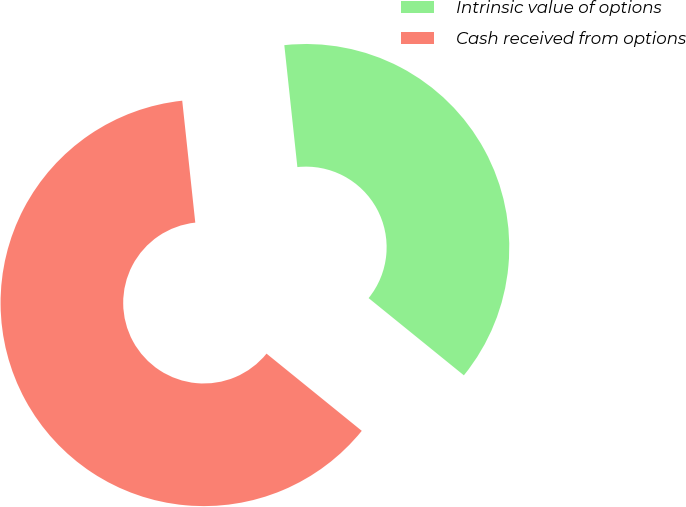<chart> <loc_0><loc_0><loc_500><loc_500><pie_chart><fcel>Intrinsic value of options<fcel>Cash received from options<nl><fcel>37.54%<fcel>62.46%<nl></chart> 